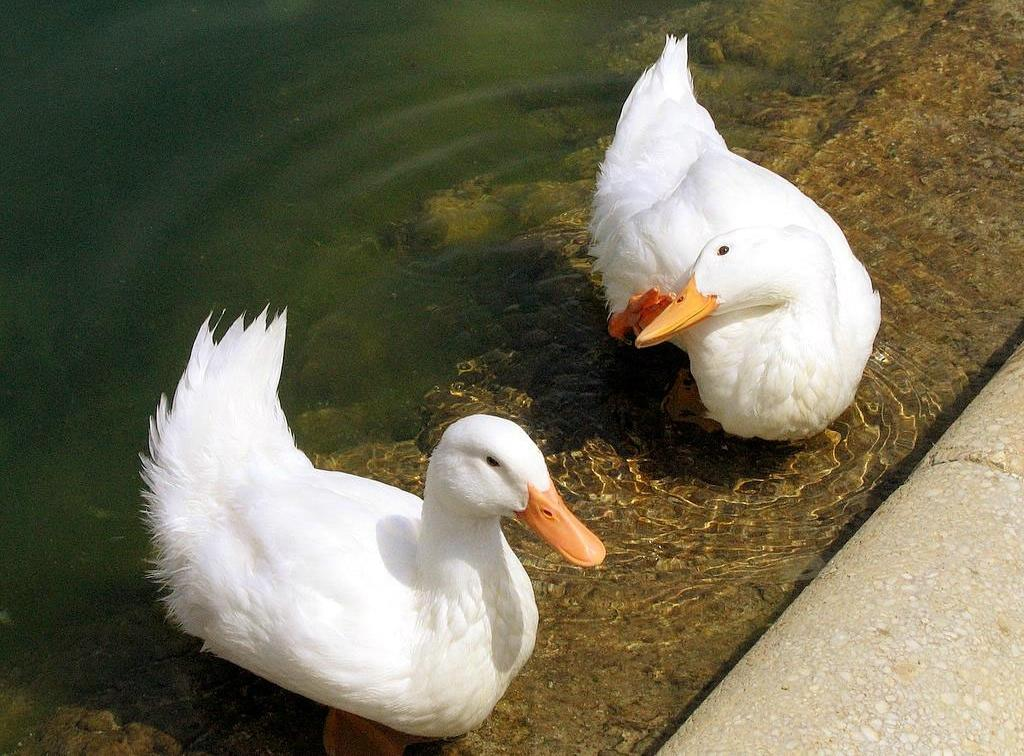What animals can be seen in the image? There are two ducks in the image. What are the ducks doing in the image? The ducks are swimming in the water. What type of terrain is visible in the bottom right of the image? There is ground visible in the bottom right of the image. What is visible in the background of the image? There is water visible in the background of the image. Can you see a swing in the image? No, there is no swing present in the image. Are there any bananas visible in the image? No, there are no bananas present in the image. 